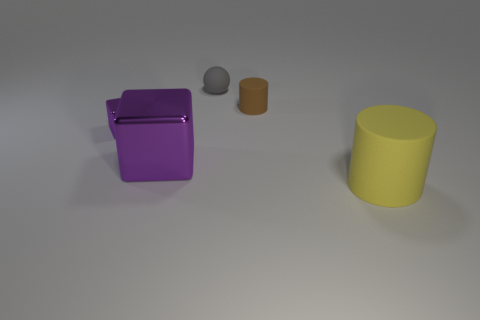Add 1 tiny yellow metallic balls. How many objects exist? 6 Subtract all spheres. How many objects are left? 4 Subtract all large yellow matte cylinders. Subtract all large purple objects. How many objects are left? 3 Add 3 large purple metal cubes. How many large purple metal cubes are left? 4 Add 3 blue metal things. How many blue metal things exist? 3 Subtract 1 gray balls. How many objects are left? 4 